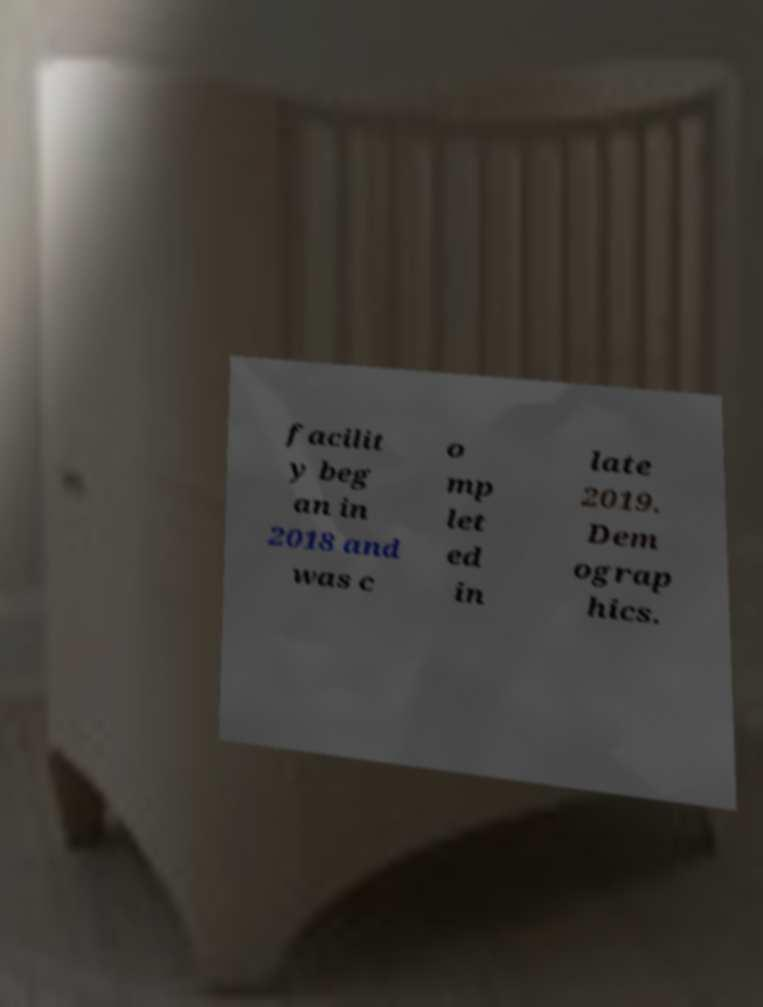There's text embedded in this image that I need extracted. Can you transcribe it verbatim? facilit y beg an in 2018 and was c o mp let ed in late 2019. Dem ograp hics. 